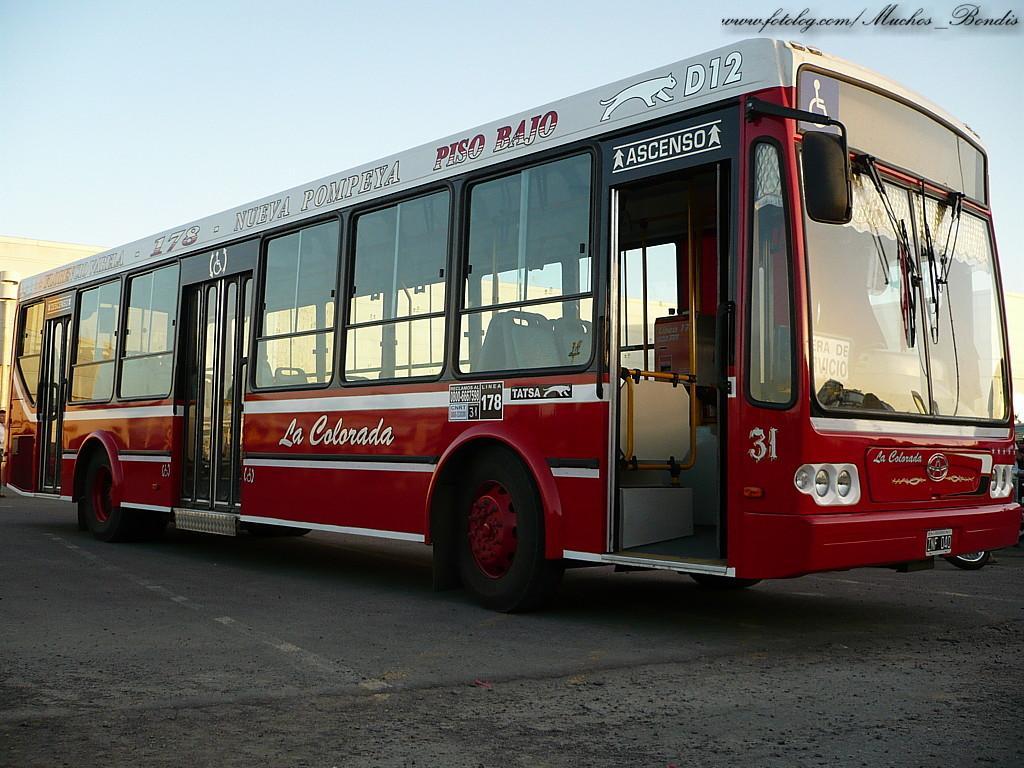Please provide a concise description of this image. In the center of the image there is a bus on the road. 